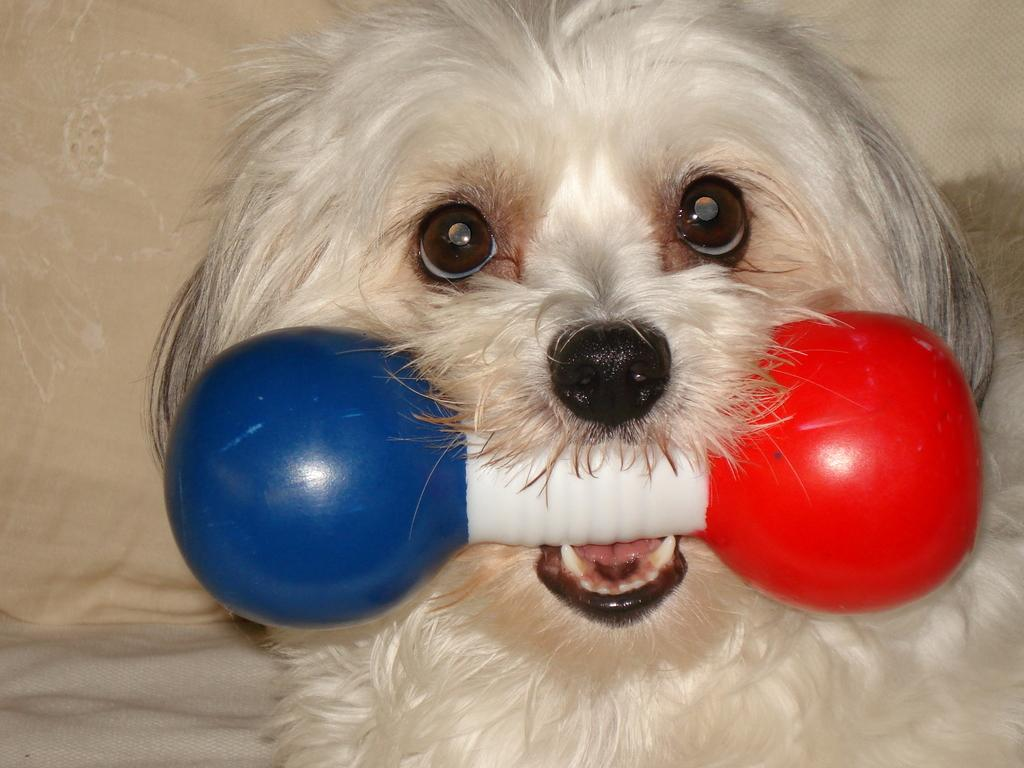What is the main subject in the foreground of the image? There is a puppy in the foreground of the image. What is the puppy doing in the image? The puppy appears to have a toy bone in its mouth. What can be seen in the background of the image? There is a pillow in the background of the image. How many pears are on the unit in the image? There are no pears or units present in the image; it features a puppy with a toy bone and a pillow in the background. Are there any spiders visible on the pillow in the image? There are no spiders visible on the pillow in the image. 